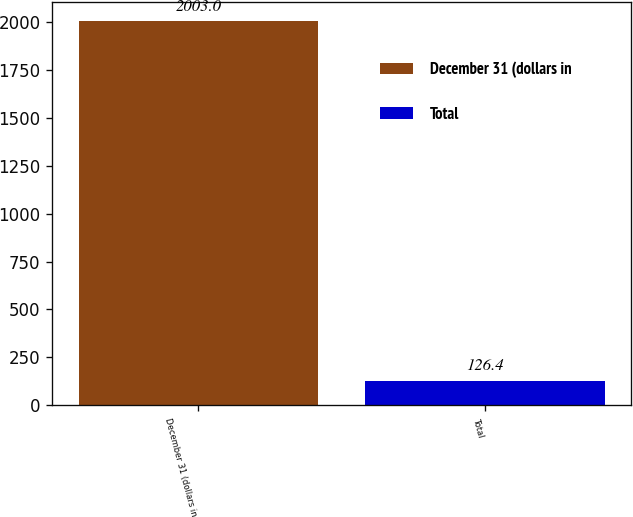<chart> <loc_0><loc_0><loc_500><loc_500><bar_chart><fcel>December 31 (dollars in<fcel>Total<nl><fcel>2003<fcel>126.4<nl></chart> 